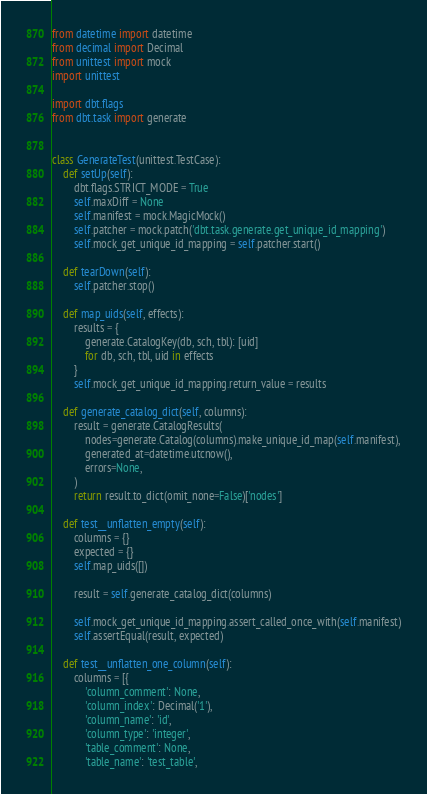Convert code to text. <code><loc_0><loc_0><loc_500><loc_500><_Python_>from datetime import datetime
from decimal import Decimal
from unittest import mock
import unittest

import dbt.flags
from dbt.task import generate


class GenerateTest(unittest.TestCase):
    def setUp(self):
        dbt.flags.STRICT_MODE = True
        self.maxDiff = None
        self.manifest = mock.MagicMock()
        self.patcher = mock.patch('dbt.task.generate.get_unique_id_mapping')
        self.mock_get_unique_id_mapping = self.patcher.start()

    def tearDown(self):
        self.patcher.stop()

    def map_uids(self, effects):
        results = {
            generate.CatalogKey(db, sch, tbl): [uid]
            for db, sch, tbl, uid in effects
        }
        self.mock_get_unique_id_mapping.return_value = results

    def generate_catalog_dict(self, columns):
        result = generate.CatalogResults(
            nodes=generate.Catalog(columns).make_unique_id_map(self.manifest),
            generated_at=datetime.utcnow(),
            errors=None,
        )
        return result.to_dict(omit_none=False)['nodes']

    def test__unflatten_empty(self):
        columns = {}
        expected = {}
        self.map_uids([])

        result = self.generate_catalog_dict(columns)

        self.mock_get_unique_id_mapping.assert_called_once_with(self.manifest)
        self.assertEqual(result, expected)

    def test__unflatten_one_column(self):
        columns = [{
            'column_comment': None,
            'column_index': Decimal('1'),
            'column_name': 'id',
            'column_type': 'integer',
            'table_comment': None,
            'table_name': 'test_table',</code> 